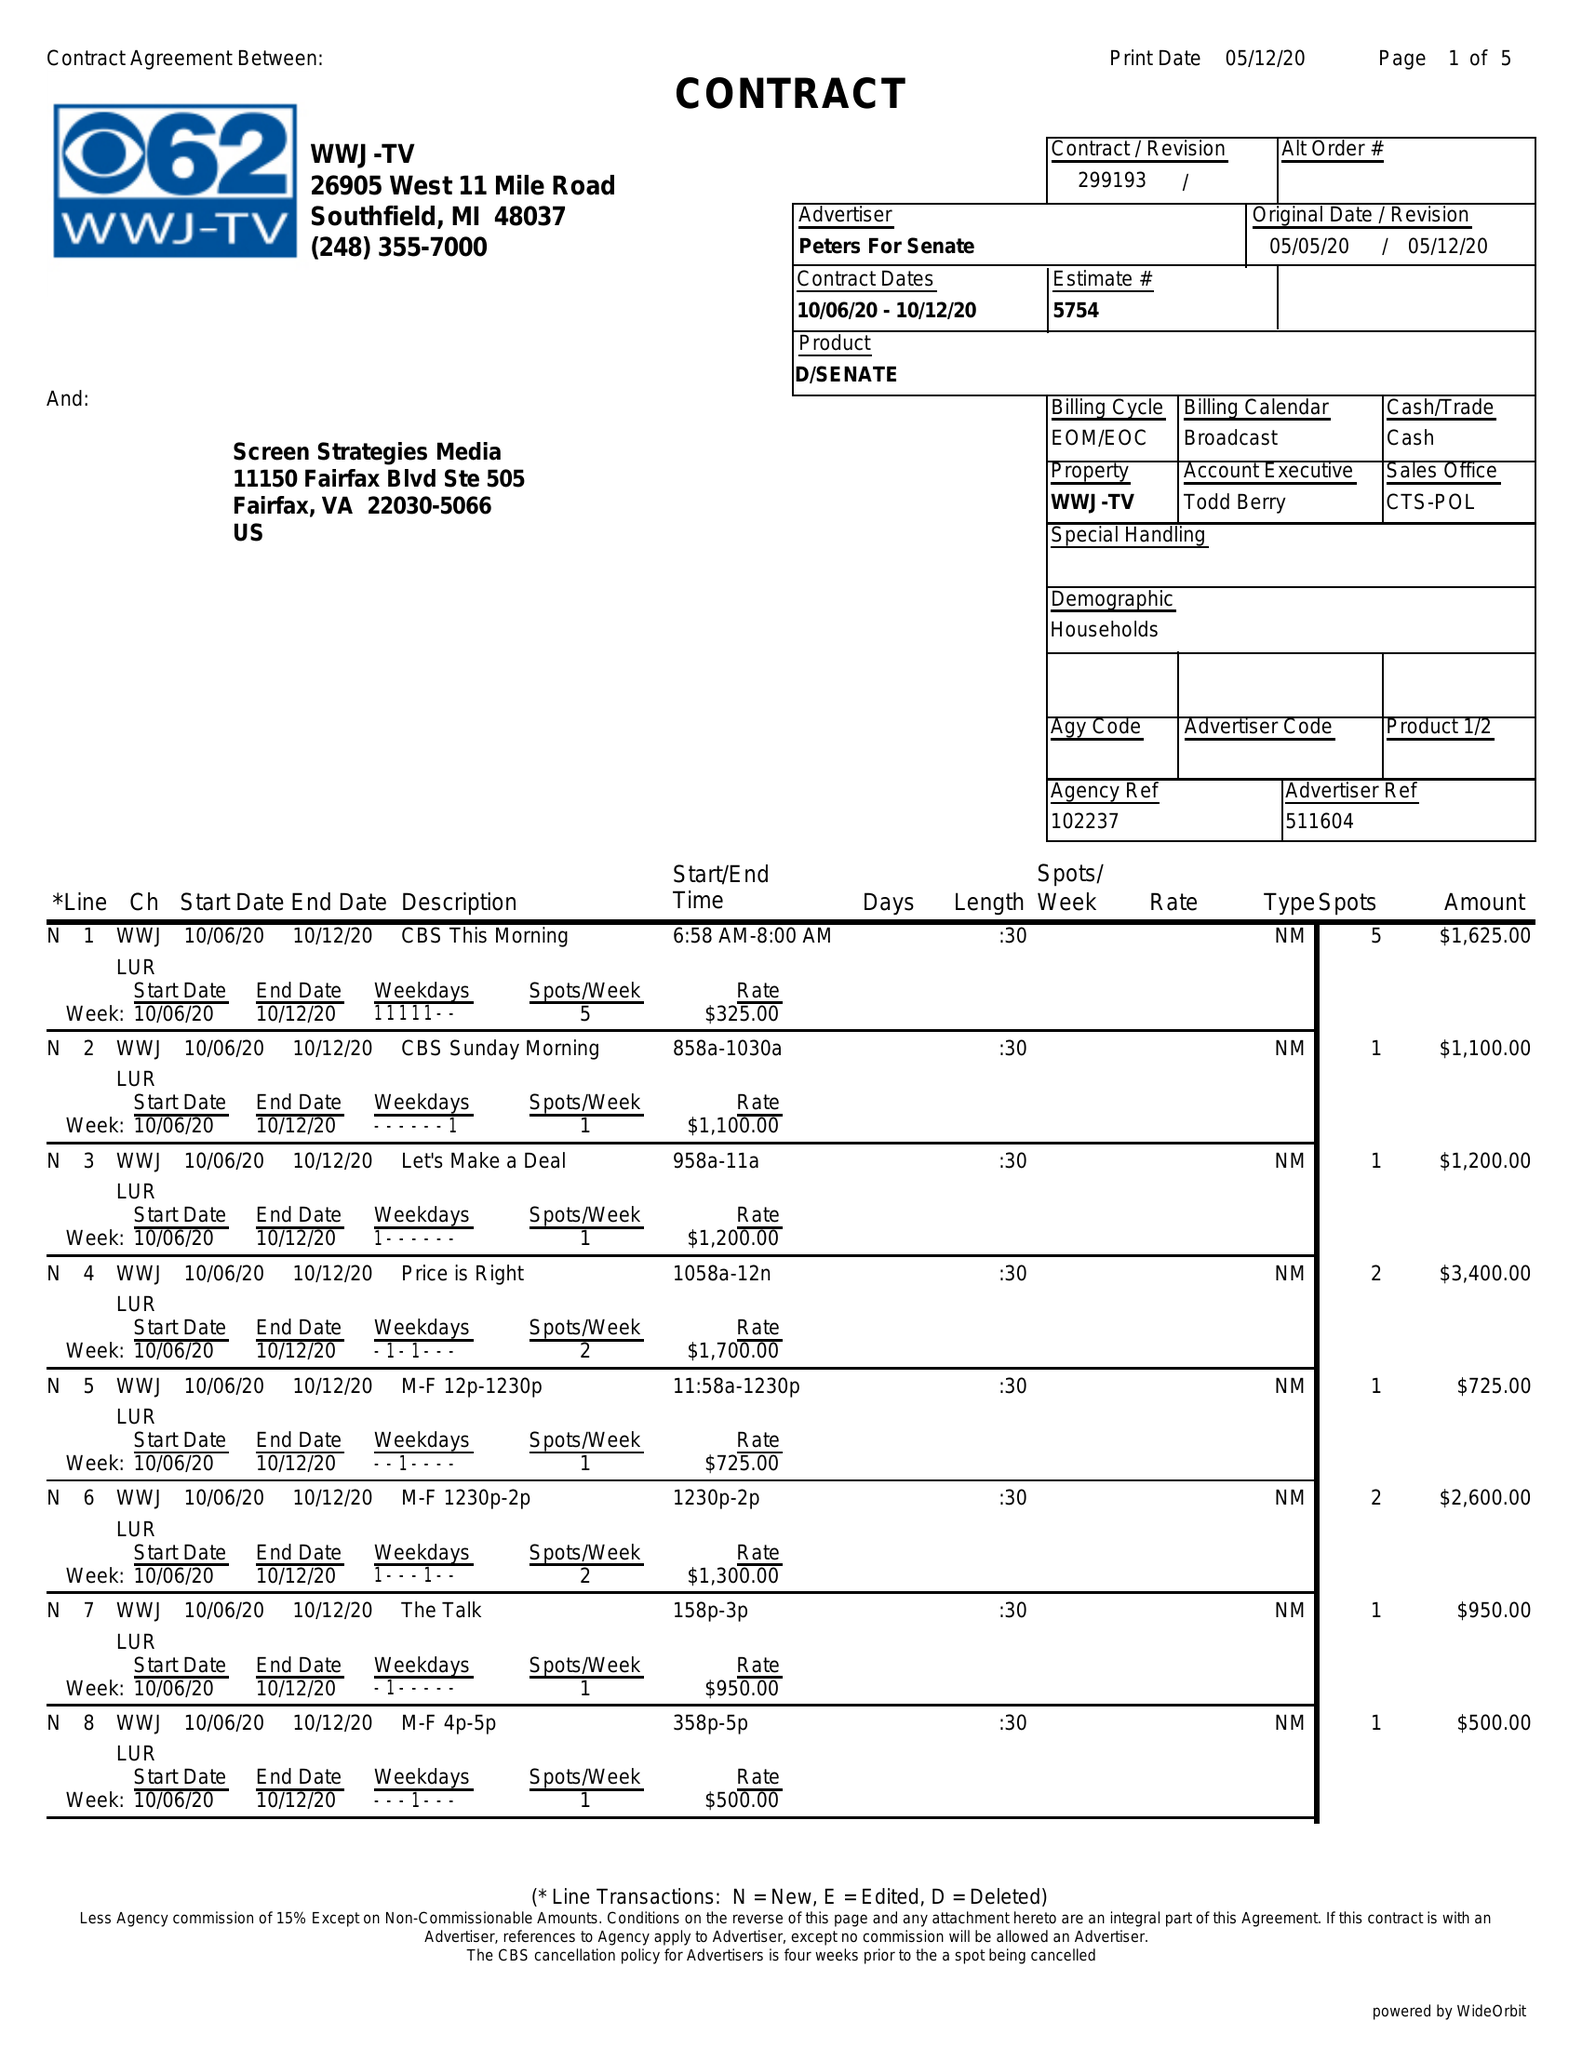What is the value for the contract_num?
Answer the question using a single word or phrase. 299193 